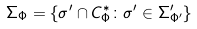Convert formula to latex. <formula><loc_0><loc_0><loc_500><loc_500>\Sigma _ { \Phi } = \{ \sigma ^ { \prime } \cap C _ { \Phi } ^ { * } \colon \sigma ^ { \prime } \in \Sigma ^ { \prime } _ { \Phi ^ { \prime } } \}</formula> 